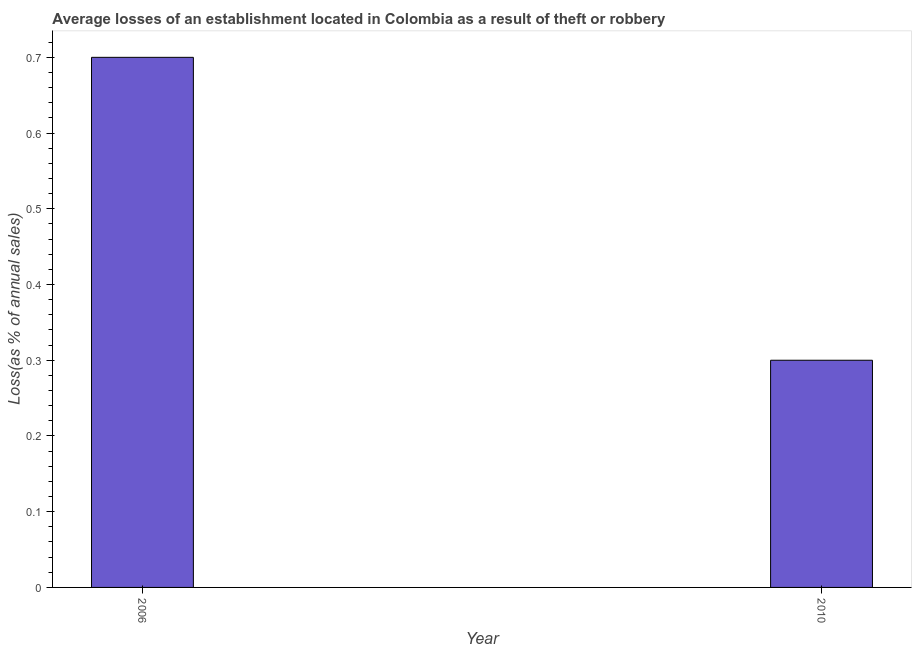Does the graph contain grids?
Provide a succinct answer. No. What is the title of the graph?
Offer a terse response. Average losses of an establishment located in Colombia as a result of theft or robbery. What is the label or title of the Y-axis?
Your response must be concise. Loss(as % of annual sales). Across all years, what is the maximum losses due to theft?
Ensure brevity in your answer.  0.7. In which year was the losses due to theft minimum?
Offer a terse response. 2010. What is the difference between the losses due to theft in 2006 and 2010?
Your response must be concise. 0.4. What is the median losses due to theft?
Your answer should be very brief. 0.5. In how many years, is the losses due to theft greater than 0.34 %?
Your response must be concise. 1. Do a majority of the years between 2006 and 2010 (inclusive) have losses due to theft greater than 0.24 %?
Your answer should be very brief. Yes. What is the ratio of the losses due to theft in 2006 to that in 2010?
Make the answer very short. 2.33. Is the losses due to theft in 2006 less than that in 2010?
Offer a terse response. No. In how many years, is the losses due to theft greater than the average losses due to theft taken over all years?
Keep it short and to the point. 1. How many bars are there?
Ensure brevity in your answer.  2. How many years are there in the graph?
Give a very brief answer. 2. What is the difference between two consecutive major ticks on the Y-axis?
Make the answer very short. 0.1. What is the Loss(as % of annual sales) in 2010?
Make the answer very short. 0.3. What is the ratio of the Loss(as % of annual sales) in 2006 to that in 2010?
Offer a very short reply. 2.33. 